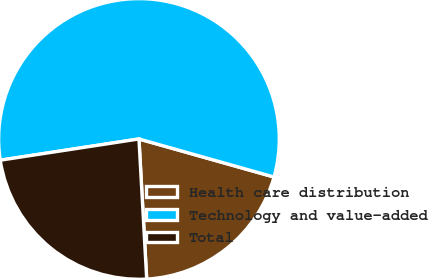Convert chart. <chart><loc_0><loc_0><loc_500><loc_500><pie_chart><fcel>Health care distribution<fcel>Technology and value-added<fcel>Total<nl><fcel>19.75%<fcel>56.79%<fcel>23.46%<nl></chart> 